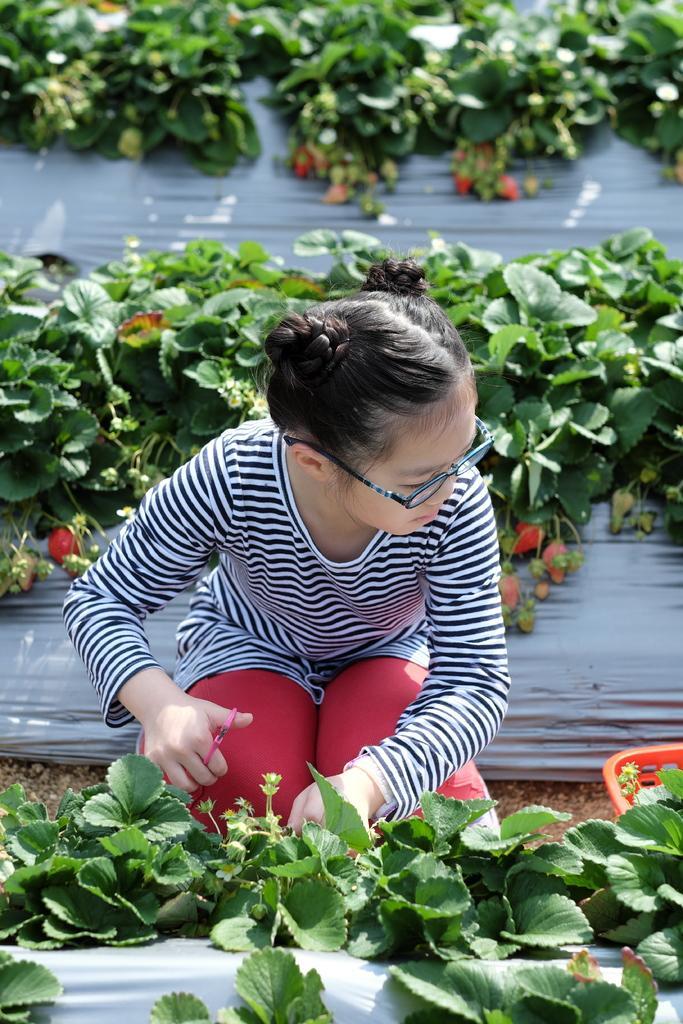Could you give a brief overview of what you see in this image? In the picture I can see a girl and she is holding a scissor in her right hand. It is looking like a garden as I can see the green plants. It is looking like a basket on the ground on the right side. 